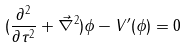<formula> <loc_0><loc_0><loc_500><loc_500>( \frac { \partial ^ { 2 } } { \partial \tau ^ { 2 } } + \vec { \nabla } ^ { 2 } ) \phi - V ^ { \prime } ( \phi ) = 0</formula> 